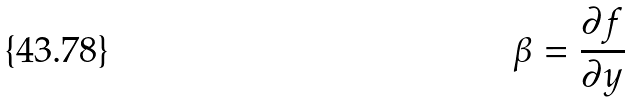Convert formula to latex. <formula><loc_0><loc_0><loc_500><loc_500>\beta = \frac { \partial f } { \partial y }</formula> 